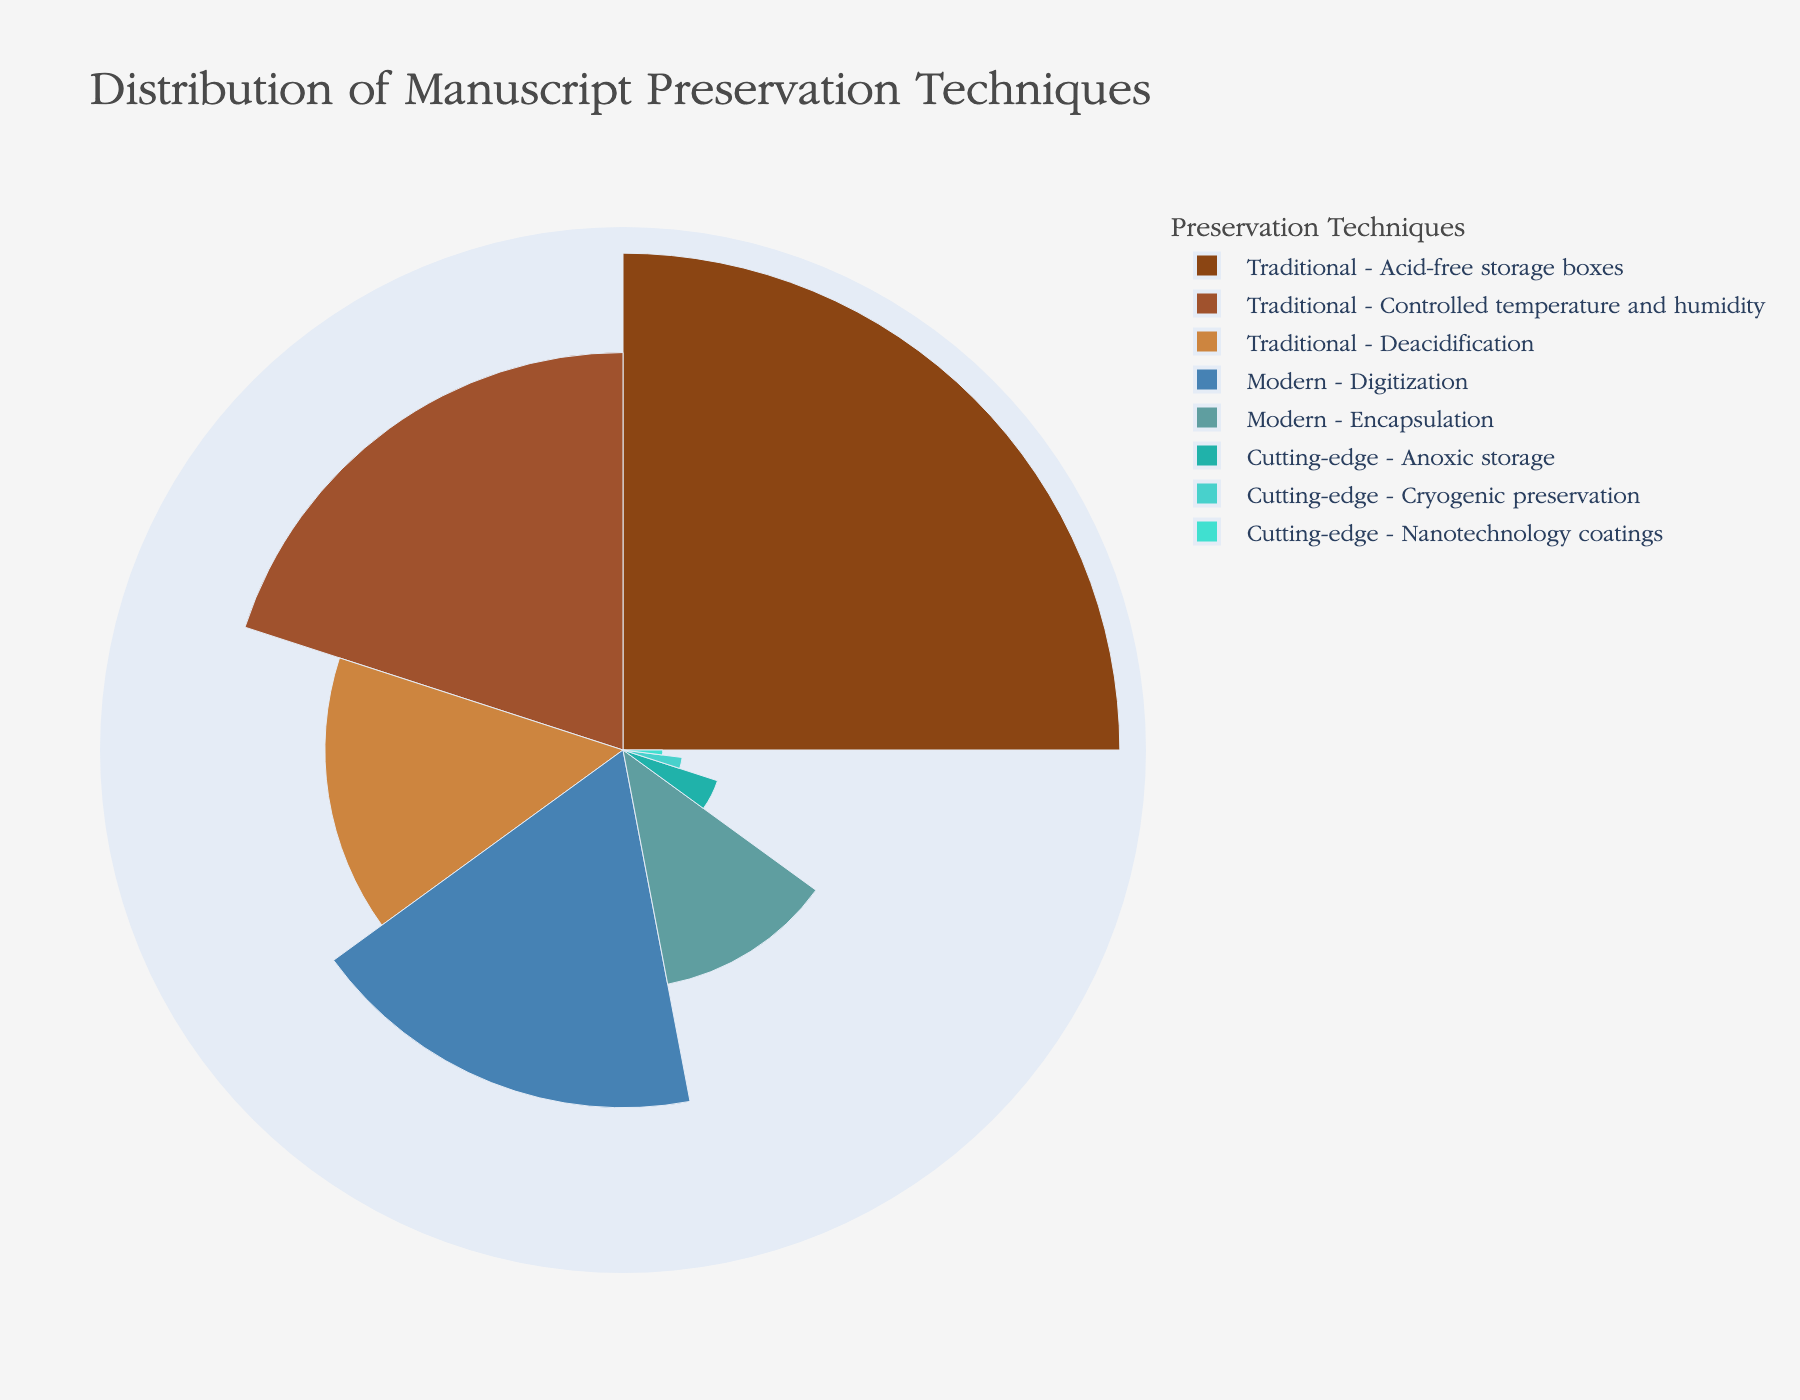What's the title of the chart? The title is typically displayed at the top of the chart. In this case, it states the name of the distribution being visualized. The title given in the chart is "Distribution of Manuscript Preservation Techniques".
Answer: Distribution of Manuscript Preservation Techniques How many techniques are classified under the 'Traditional' category? To determine the number of techniques classified under the 'Traditional' category, count all the techniques listed under that specific category. There are three techniques: Acid-free storage boxes, Controlled temperature and humidity, and Deacidification.
Answer: Three Which technique has the highest percentage of use? By looking at the lengths and positions of the polar bars in the chart, you can find the one with the highest percentage. In this case, the technique with the highest percentage is Acid-free storage boxes under the 'Traditional' category.
Answer: Acid-free storage boxes What is the combined percentage of the 'Cutting-edge' preservation techniques? To find the combined percentage, sum the percentages of all the 'Cutting-edge' techniques: Anoxic storage (5%), Cryogenic preservation (3%), and Nanotechnology coatings (2%). Adding 5 + 3 + 2 gives 10%.
Answer: 10% Which 'Modern' technique has a higher percentage, Digitization or Encapsulation? Look at the percentages for Digitization and Encapsulation in the 'Modern' category. Digitization has 18% and Encapsulation has 12%. Therefore, Digitization has a higher percentage.
Answer: Digitization Are traditional techniques used more often than modern techniques? Sum the percentages of the 'Traditional' and 'Modern' techniques. Traditional: 25% + 20% + 15% = 60%. Modern: 18% + 12% = 30%. So, traditional techniques are used more often.
Answer: Yes What is the percentage difference between the most used traditional technique and the most used modern technique? Compare the highest percentage in the 'Traditional' category (Acid-free storage boxes, 25%) to the highest in the 'Modern' category (Digitization, 18%). The difference is 25% - 18% = 7%.
Answer: 7% Which category has the least number of techniques? Count the techniques in each category. 'Traditional' has 3, 'Modern' has 2, and 'Cutting-edge' has 3. Thus, 'Modern' has the least number of techniques.
Answer: Modern What percentage of the techniques are used by only one method? Identify techniques with the lowest percentage. Only Nanotechnology coatings have a unique percentage of 2%. Since there are 8 techniques in total, 2/8 * 100% = 25%.
Answer: 25% What percentage do traditional and cutting-edge techniques comprise together? Sum the percentages of both 'Traditional' and 'Cutting-edge' techniques. Traditional: 25% + 20% + 15% = 60%. Cutting-edge: 5% + 3% + 2% = 10%. 60% + 10% = 70%.
Answer: 70% 